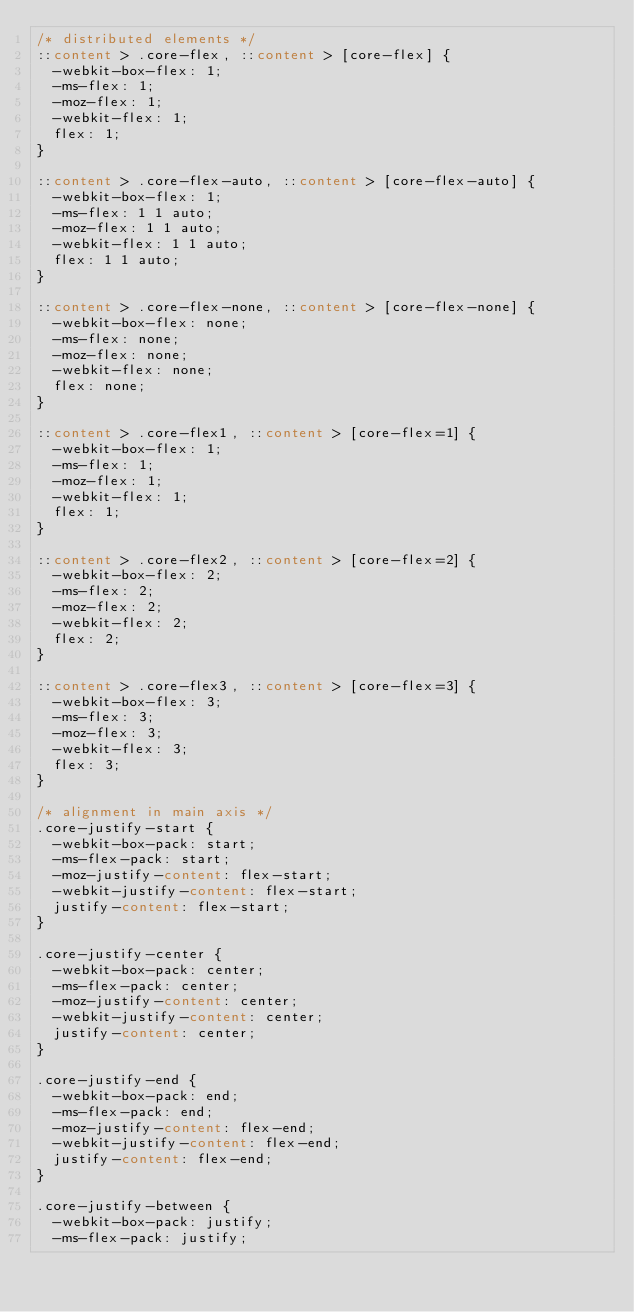<code> <loc_0><loc_0><loc_500><loc_500><_CSS_>/* distributed elements */
::content > .core-flex, ::content > [core-flex] {
  -webkit-box-flex: 1;
  -ms-flex: 1;
  -moz-flex: 1;
  -webkit-flex: 1;
  flex: 1;
}

::content > .core-flex-auto, ::content > [core-flex-auto] {
  -webkit-box-flex: 1;
  -ms-flex: 1 1 auto;
  -moz-flex: 1 1 auto;
  -webkit-flex: 1 1 auto;
  flex: 1 1 auto;
}

::content > .core-flex-none, ::content > [core-flex-none] {
  -webkit-box-flex: none;
  -ms-flex: none;
  -moz-flex: none;
  -webkit-flex: none;
  flex: none;
}

::content > .core-flex1, ::content > [core-flex=1] {
  -webkit-box-flex: 1;
  -ms-flex: 1;
  -moz-flex: 1;
  -webkit-flex: 1;
  flex: 1;
}

::content > .core-flex2, ::content > [core-flex=2] {
  -webkit-box-flex: 2;
  -ms-flex: 2;
  -moz-flex: 2;
  -webkit-flex: 2;
  flex: 2;
}

::content > .core-flex3, ::content > [core-flex=3] {
  -webkit-box-flex: 3;
  -ms-flex: 3;
  -moz-flex: 3;
  -webkit-flex: 3;
  flex: 3;
}

/* alignment in main axis */
.core-justify-start {
  -webkit-box-pack: start;
  -ms-flex-pack: start;
  -moz-justify-content: flex-start;
  -webkit-justify-content: flex-start;
  justify-content: flex-start;
}

.core-justify-center {
  -webkit-box-pack: center;
  -ms-flex-pack: center;
  -moz-justify-content: center;
  -webkit-justify-content: center;
  justify-content: center;
}

.core-justify-end {
  -webkit-box-pack: end;
  -ms-flex-pack: end;
  -moz-justify-content: flex-end;
  -webkit-justify-content: flex-end;
  justify-content: flex-end;
}

.core-justify-between {
  -webkit-box-pack: justify;
  -ms-flex-pack: justify;</code> 